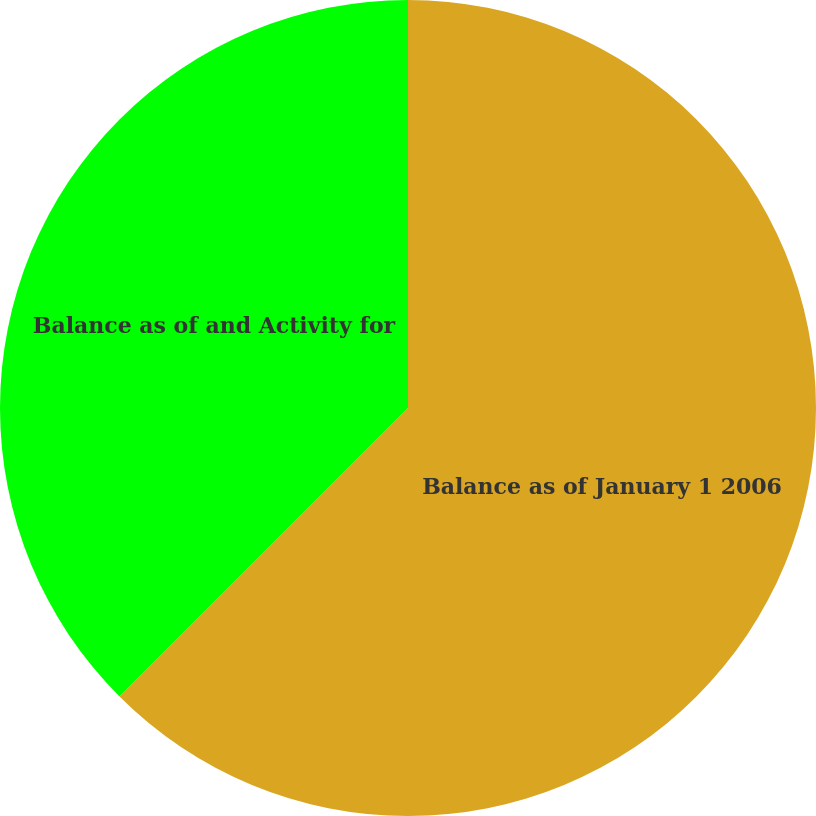Convert chart. <chart><loc_0><loc_0><loc_500><loc_500><pie_chart><fcel>Balance as of January 1 2006<fcel>Balance as of and Activity for<nl><fcel>62.5%<fcel>37.5%<nl></chart> 